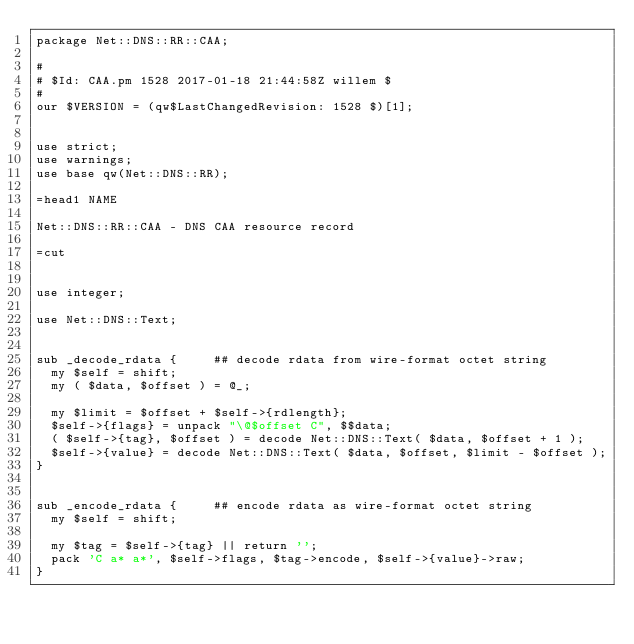Convert code to text. <code><loc_0><loc_0><loc_500><loc_500><_Perl_>package Net::DNS::RR::CAA;

#
# $Id: CAA.pm 1528 2017-01-18 21:44:58Z willem $
#
our $VERSION = (qw$LastChangedRevision: 1528 $)[1];


use strict;
use warnings;
use base qw(Net::DNS::RR);

=head1 NAME

Net::DNS::RR::CAA - DNS CAA resource record

=cut


use integer;

use Net::DNS::Text;


sub _decode_rdata {			## decode rdata from wire-format octet string
	my $self = shift;
	my ( $data, $offset ) = @_;

	my $limit = $offset + $self->{rdlength};
	$self->{flags} = unpack "\@$offset C", $$data;
	( $self->{tag}, $offset ) = decode Net::DNS::Text( $data, $offset + 1 );
	$self->{value} = decode Net::DNS::Text( $data, $offset, $limit - $offset );
}


sub _encode_rdata {			## encode rdata as wire-format octet string
	my $self = shift;

	my $tag = $self->{tag} || return '';
	pack 'C a* a*', $self->flags, $tag->encode, $self->{value}->raw;
}

</code> 